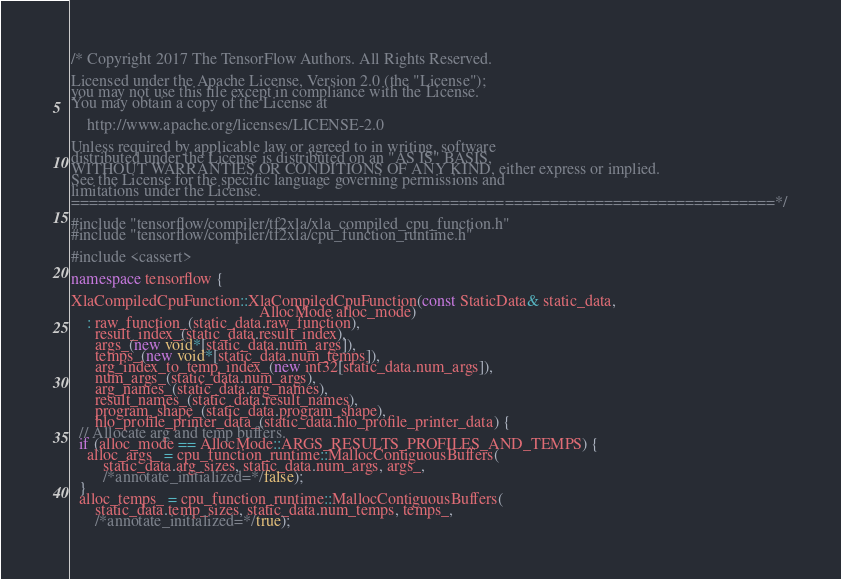Convert code to text. <code><loc_0><loc_0><loc_500><loc_500><_C++_>/* Copyright 2017 The TensorFlow Authors. All Rights Reserved.

Licensed under the Apache License, Version 2.0 (the "License");
you may not use this file except in compliance with the License.
You may obtain a copy of the License at

    http://www.apache.org/licenses/LICENSE-2.0

Unless required by applicable law or agreed to in writing, software
distributed under the License is distributed on an "AS IS" BASIS,
WITHOUT WARRANTIES OR CONDITIONS OF ANY KIND, either express or implied.
See the License for the specific language governing permissions and
limitations under the License.
==============================================================================*/

#include "tensorflow/compiler/tf2xla/xla_compiled_cpu_function.h"
#include "tensorflow/compiler/tf2xla/cpu_function_runtime.h"

#include <cassert>

namespace tensorflow {

XlaCompiledCpuFunction::XlaCompiledCpuFunction(const StaticData& static_data,
                                               AllocMode alloc_mode)
    : raw_function_(static_data.raw_function),
      result_index_(static_data.result_index),
      args_(new void*[static_data.num_args]),
      temps_(new void*[static_data.num_temps]),
      arg_index_to_temp_index_(new int32[static_data.num_args]),
      num_args_(static_data.num_args),
      arg_names_(static_data.arg_names),
      result_names_(static_data.result_names),
      program_shape_(static_data.program_shape),
      hlo_profile_printer_data_(static_data.hlo_profile_printer_data) {
  // Allocate arg and temp buffers.
  if (alloc_mode == AllocMode::ARGS_RESULTS_PROFILES_AND_TEMPS) {
    alloc_args_ = cpu_function_runtime::MallocContiguousBuffers(
        static_data.arg_sizes, static_data.num_args, args_,
        /*annotate_initialized=*/false);
  }
  alloc_temps_ = cpu_function_runtime::MallocContiguousBuffers(
      static_data.temp_sizes, static_data.num_temps, temps_,
      /*annotate_initialized=*/true);
</code> 